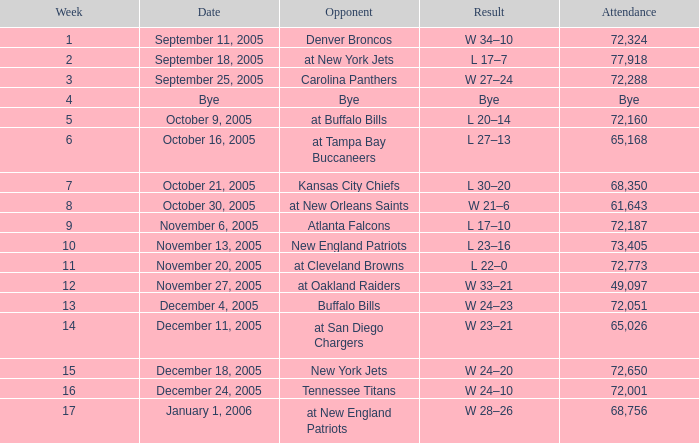What is the Week with a Date of Bye? 1.0. 